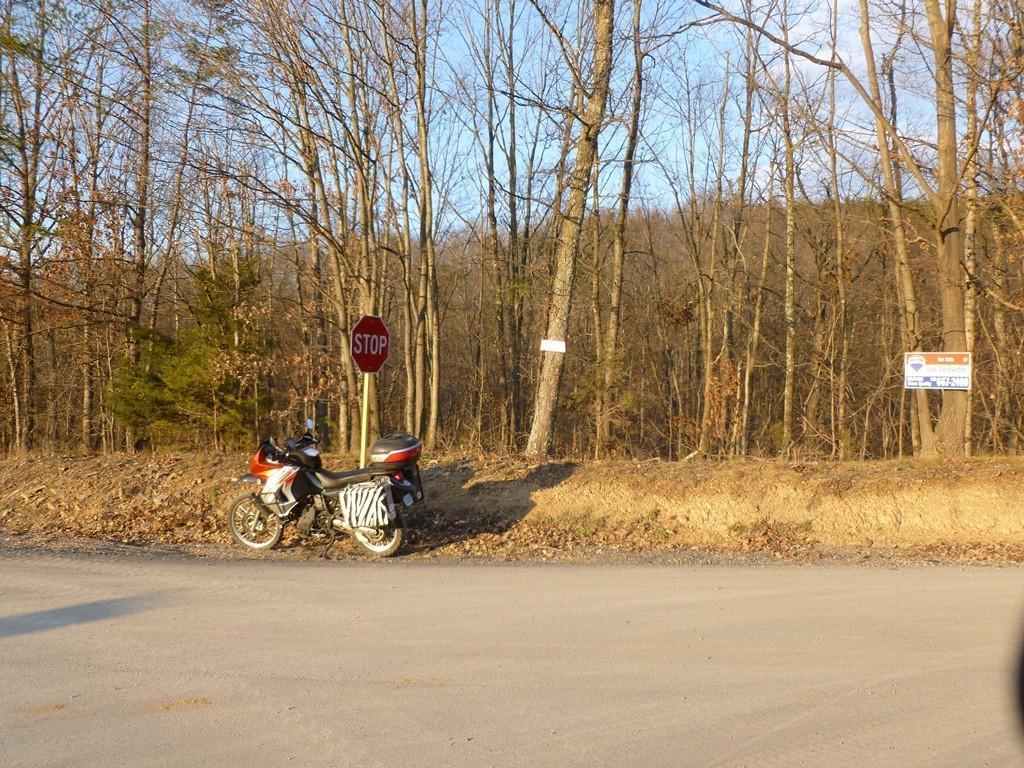Can you describe this image briefly? In this image we can see many trees. There is a vehicle in the image. There is a road at the bottom of the image. There are few boards in the image. There is a stop sign board in the image. We can see the sky in the image. 